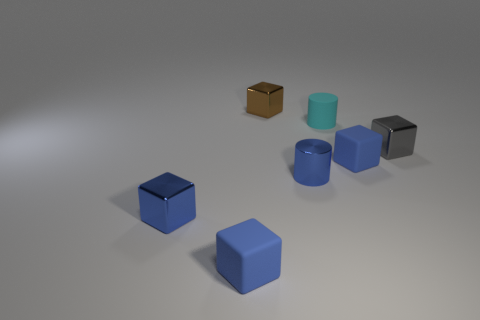How many blue cubes must be subtracted to get 1 blue cubes? 2 Subtract all gray cylinders. How many blue blocks are left? 3 Subtract 3 blocks. How many blocks are left? 2 Subtract all gray blocks. How many blocks are left? 4 Subtract all tiny blue metallic cubes. How many cubes are left? 4 Add 1 yellow cylinders. How many objects exist? 8 Subtract all purple blocks. Subtract all red balls. How many blocks are left? 5 Subtract all cylinders. How many objects are left? 5 Subtract all green objects. Subtract all cyan rubber objects. How many objects are left? 6 Add 6 tiny rubber objects. How many tiny rubber objects are left? 9 